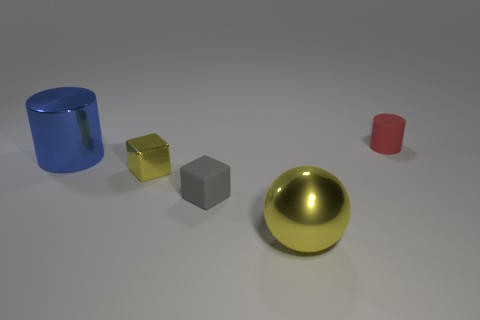Is the size of the yellow sphere the same as the yellow metallic block?
Provide a succinct answer. No. What number of spheres are small cyan things or tiny shiny objects?
Your answer should be compact. 0. What is the material of the sphere that is the same color as the shiny cube?
Offer a very short reply. Metal. What number of blue objects have the same shape as the big yellow shiny object?
Keep it short and to the point. 0. Are there more gray cubes that are behind the big blue metal cylinder than large metallic objects that are right of the tiny red matte cylinder?
Keep it short and to the point. No. There is a thing behind the blue shiny cylinder; does it have the same color as the sphere?
Your answer should be compact. No. How big is the blue cylinder?
Make the answer very short. Large. What material is the yellow block that is the same size as the gray rubber cube?
Your answer should be very brief. Metal. There is a matte object that is to the right of the shiny sphere; what is its color?
Your response must be concise. Red. What number of small gray cubes are there?
Offer a very short reply. 1. 